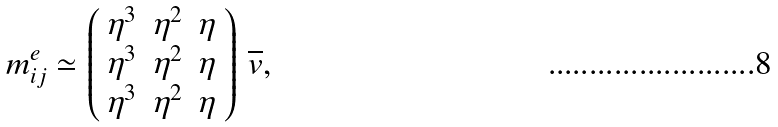Convert formula to latex. <formula><loc_0><loc_0><loc_500><loc_500>m ^ { e } _ { i j } \simeq \left ( \begin{array} { c c c } \eta ^ { 3 } & \eta ^ { 2 } & \eta \\ \eta ^ { 3 } & \eta ^ { 2 } & \eta \\ \eta ^ { 3 } & \eta ^ { 2 } & \eta \\ \end{array} \right ) \, \overline { v } ,</formula> 